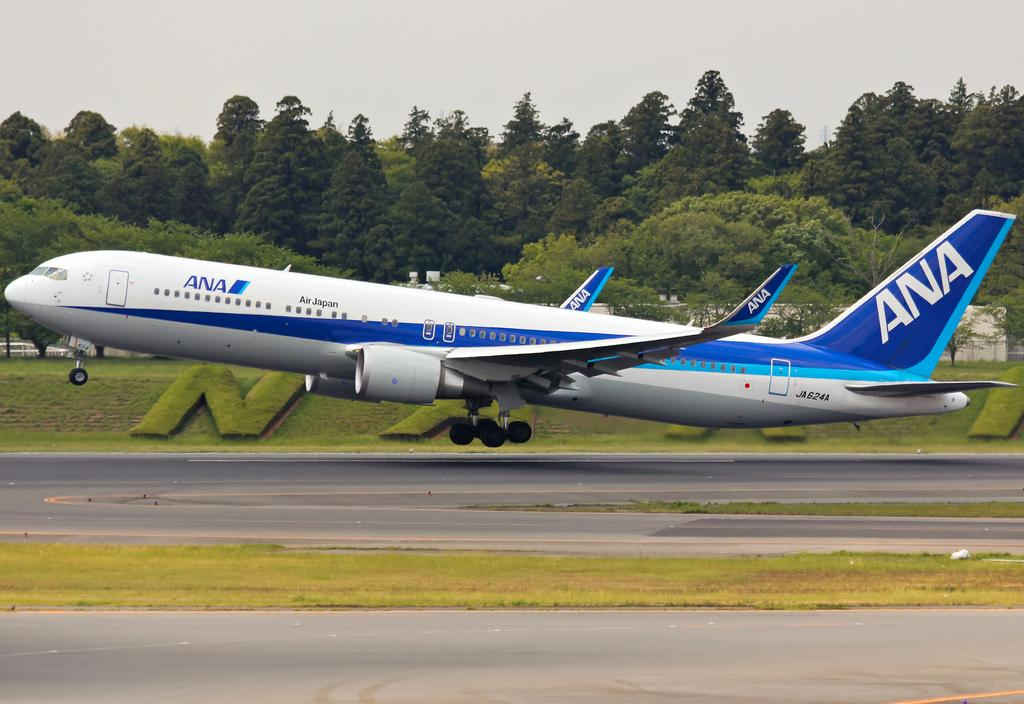What is the main subject of the image? The main subject of the image is an airplane. What is the airplane doing in the image? The airplane is taking off on a road. What type of environment surrounds the road in the image? Grassland is present on either side of the road. What can be seen in the background of the image? There are trees in the background of the image. What is visible above the image? The sky is visible above the image. What type of jewel can be seen on the airplane's wing in the image? There is no jewel present on the airplane's wing in the image. Can you describe the insect that is flying near the airplane in the image? There is no insect present near the airplane in the image. 